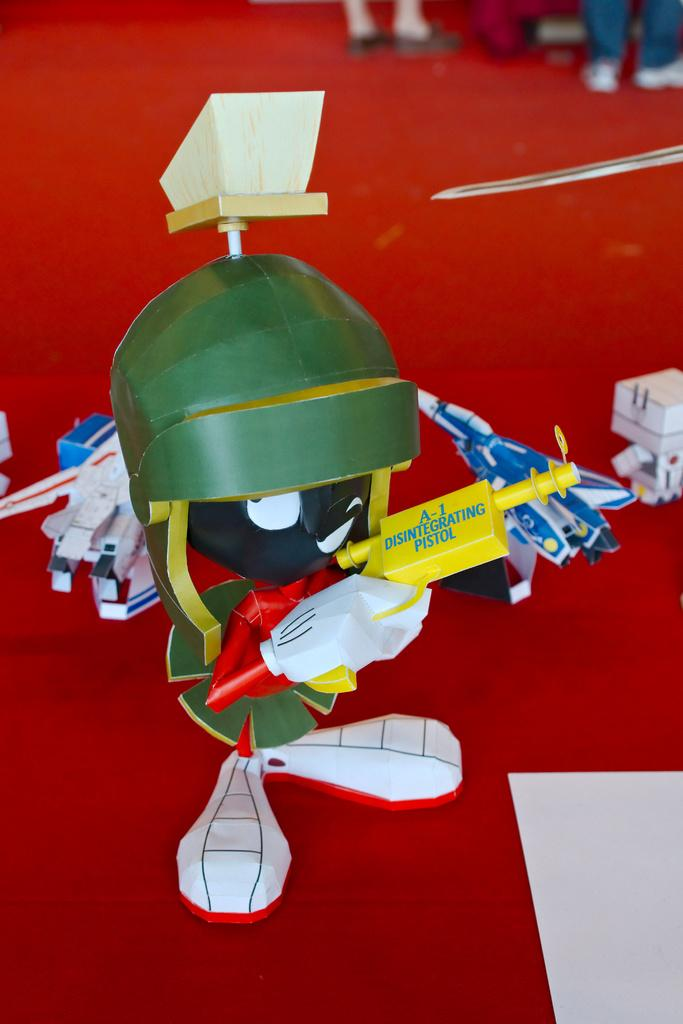What is on the floor in the image? There are toys on the floor in the image. How many people are visible in the image? There are two persons standing at the back of the image. Can you describe the object on the red carpet? There is a white paper on the red carpet at the bottom right of the image. What type of plant is growing on the white paper in the image? There is no plant growing on the white paper in the image; it is a piece of paper on a red carpet. What type of work are the two persons doing in the image? The provided facts do not mention any work being done by the two persons in the image. 